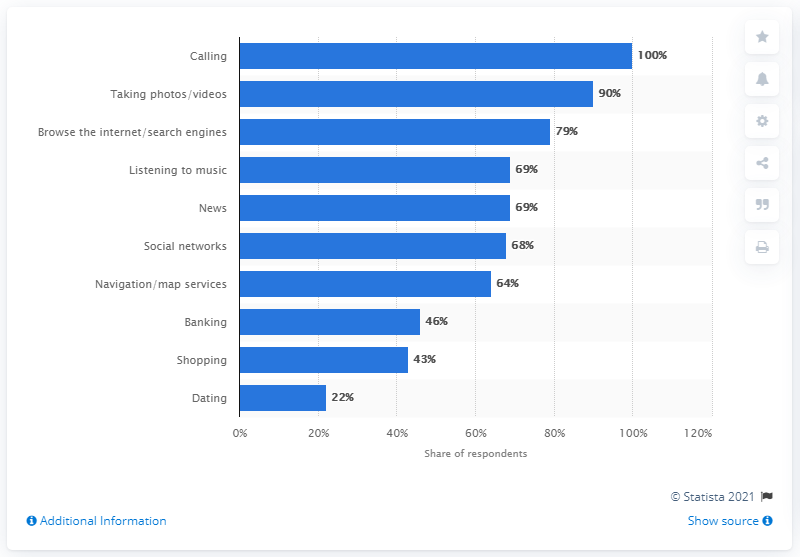Identify some key points in this picture. During the survey period, 68% of smartphone users reported accessing social networks on their mobile device. 